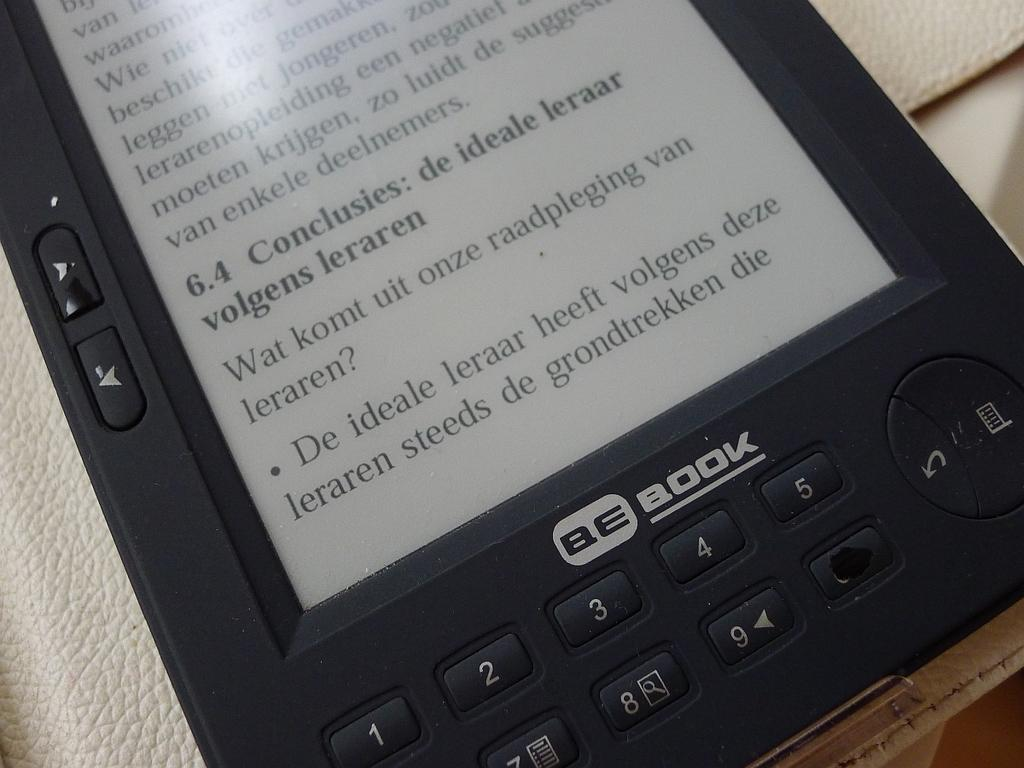Provide a one-sentence caption for the provided image. A tablet that is displaying a foreign language and BE Book on it. 